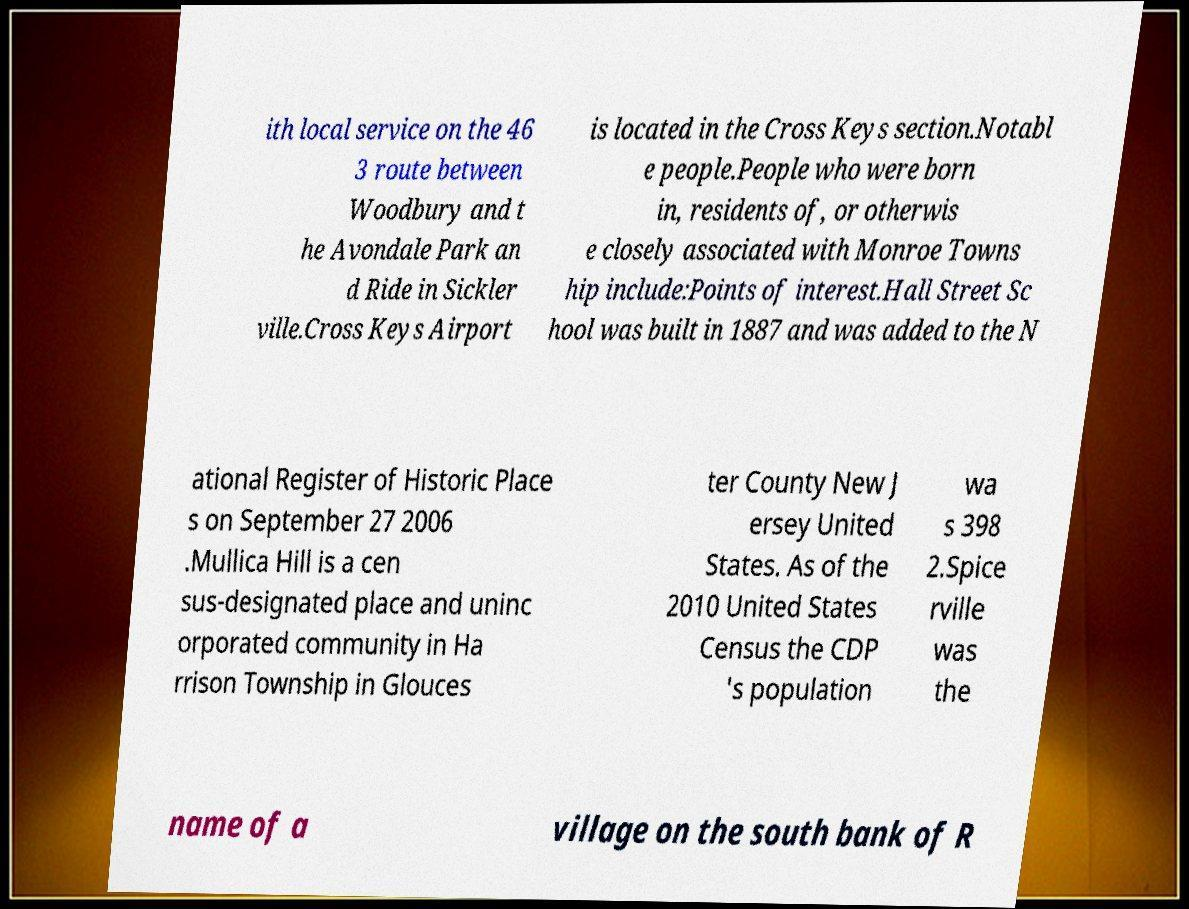Could you extract and type out the text from this image? ith local service on the 46 3 route between Woodbury and t he Avondale Park an d Ride in Sickler ville.Cross Keys Airport is located in the Cross Keys section.Notabl e people.People who were born in, residents of, or otherwis e closely associated with Monroe Towns hip include:Points of interest.Hall Street Sc hool was built in 1887 and was added to the N ational Register of Historic Place s on September 27 2006 .Mullica Hill is a cen sus-designated place and uninc orporated community in Ha rrison Township in Glouces ter County New J ersey United States. As of the 2010 United States Census the CDP 's population wa s 398 2.Spice rville was the name of a village on the south bank of R 